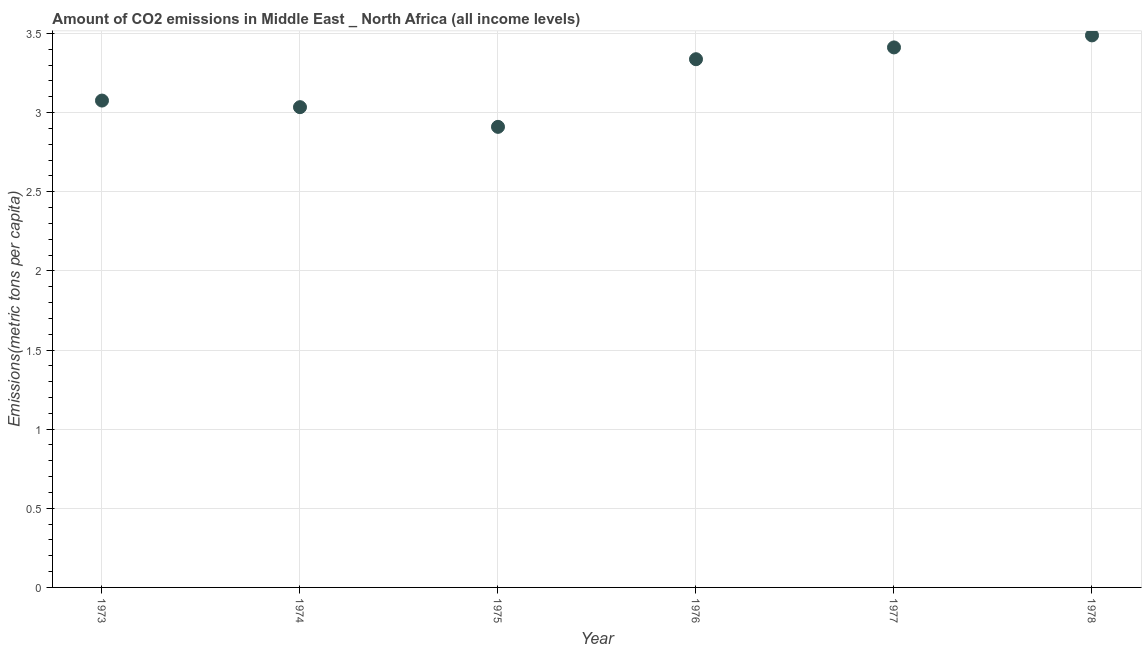What is the amount of co2 emissions in 1977?
Give a very brief answer. 3.41. Across all years, what is the maximum amount of co2 emissions?
Give a very brief answer. 3.49. Across all years, what is the minimum amount of co2 emissions?
Make the answer very short. 2.91. In which year was the amount of co2 emissions maximum?
Provide a succinct answer. 1978. In which year was the amount of co2 emissions minimum?
Offer a terse response. 1975. What is the sum of the amount of co2 emissions?
Offer a very short reply. 19.26. What is the difference between the amount of co2 emissions in 1974 and 1975?
Provide a succinct answer. 0.12. What is the average amount of co2 emissions per year?
Your response must be concise. 3.21. What is the median amount of co2 emissions?
Give a very brief answer. 3.21. What is the ratio of the amount of co2 emissions in 1976 to that in 1978?
Your answer should be very brief. 0.96. What is the difference between the highest and the second highest amount of co2 emissions?
Your answer should be compact. 0.08. What is the difference between the highest and the lowest amount of co2 emissions?
Provide a short and direct response. 0.58. In how many years, is the amount of co2 emissions greater than the average amount of co2 emissions taken over all years?
Make the answer very short. 3. Does the amount of co2 emissions monotonically increase over the years?
Provide a succinct answer. No. How many years are there in the graph?
Keep it short and to the point. 6. What is the title of the graph?
Your answer should be very brief. Amount of CO2 emissions in Middle East _ North Africa (all income levels). What is the label or title of the Y-axis?
Your answer should be compact. Emissions(metric tons per capita). What is the Emissions(metric tons per capita) in 1973?
Your answer should be very brief. 3.08. What is the Emissions(metric tons per capita) in 1974?
Your answer should be compact. 3.03. What is the Emissions(metric tons per capita) in 1975?
Ensure brevity in your answer.  2.91. What is the Emissions(metric tons per capita) in 1976?
Provide a succinct answer. 3.34. What is the Emissions(metric tons per capita) in 1977?
Your answer should be compact. 3.41. What is the Emissions(metric tons per capita) in 1978?
Offer a very short reply. 3.49. What is the difference between the Emissions(metric tons per capita) in 1973 and 1974?
Give a very brief answer. 0.04. What is the difference between the Emissions(metric tons per capita) in 1973 and 1975?
Ensure brevity in your answer.  0.17. What is the difference between the Emissions(metric tons per capita) in 1973 and 1976?
Provide a short and direct response. -0.26. What is the difference between the Emissions(metric tons per capita) in 1973 and 1977?
Provide a succinct answer. -0.34. What is the difference between the Emissions(metric tons per capita) in 1973 and 1978?
Your answer should be compact. -0.41. What is the difference between the Emissions(metric tons per capita) in 1974 and 1975?
Give a very brief answer. 0.12. What is the difference between the Emissions(metric tons per capita) in 1974 and 1976?
Give a very brief answer. -0.3. What is the difference between the Emissions(metric tons per capita) in 1974 and 1977?
Offer a very short reply. -0.38. What is the difference between the Emissions(metric tons per capita) in 1974 and 1978?
Your answer should be compact. -0.45. What is the difference between the Emissions(metric tons per capita) in 1975 and 1976?
Your answer should be very brief. -0.43. What is the difference between the Emissions(metric tons per capita) in 1975 and 1977?
Provide a succinct answer. -0.5. What is the difference between the Emissions(metric tons per capita) in 1975 and 1978?
Give a very brief answer. -0.58. What is the difference between the Emissions(metric tons per capita) in 1976 and 1977?
Keep it short and to the point. -0.07. What is the difference between the Emissions(metric tons per capita) in 1976 and 1978?
Your response must be concise. -0.15. What is the difference between the Emissions(metric tons per capita) in 1977 and 1978?
Your response must be concise. -0.08. What is the ratio of the Emissions(metric tons per capita) in 1973 to that in 1975?
Provide a succinct answer. 1.06. What is the ratio of the Emissions(metric tons per capita) in 1973 to that in 1976?
Make the answer very short. 0.92. What is the ratio of the Emissions(metric tons per capita) in 1973 to that in 1977?
Provide a succinct answer. 0.9. What is the ratio of the Emissions(metric tons per capita) in 1973 to that in 1978?
Keep it short and to the point. 0.88. What is the ratio of the Emissions(metric tons per capita) in 1974 to that in 1975?
Provide a short and direct response. 1.04. What is the ratio of the Emissions(metric tons per capita) in 1974 to that in 1976?
Your answer should be very brief. 0.91. What is the ratio of the Emissions(metric tons per capita) in 1974 to that in 1977?
Provide a short and direct response. 0.89. What is the ratio of the Emissions(metric tons per capita) in 1974 to that in 1978?
Offer a very short reply. 0.87. What is the ratio of the Emissions(metric tons per capita) in 1975 to that in 1976?
Make the answer very short. 0.87. What is the ratio of the Emissions(metric tons per capita) in 1975 to that in 1977?
Your response must be concise. 0.85. What is the ratio of the Emissions(metric tons per capita) in 1975 to that in 1978?
Your answer should be compact. 0.83. What is the ratio of the Emissions(metric tons per capita) in 1976 to that in 1978?
Your answer should be very brief. 0.96. What is the ratio of the Emissions(metric tons per capita) in 1977 to that in 1978?
Provide a succinct answer. 0.98. 